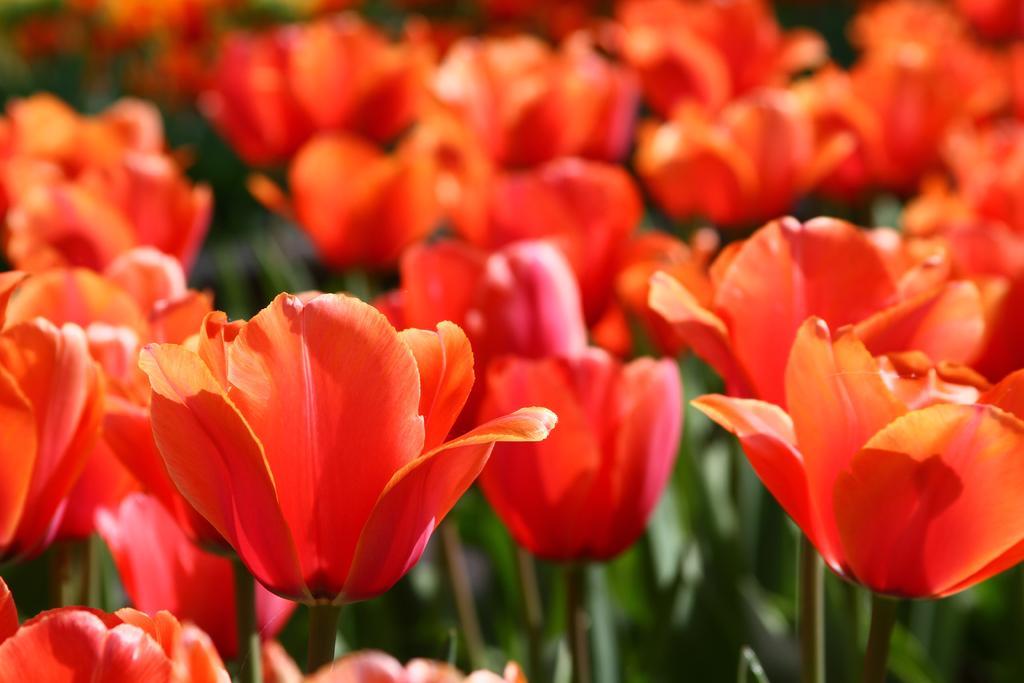Can you describe this image briefly? In this image, we can see some flowers. 